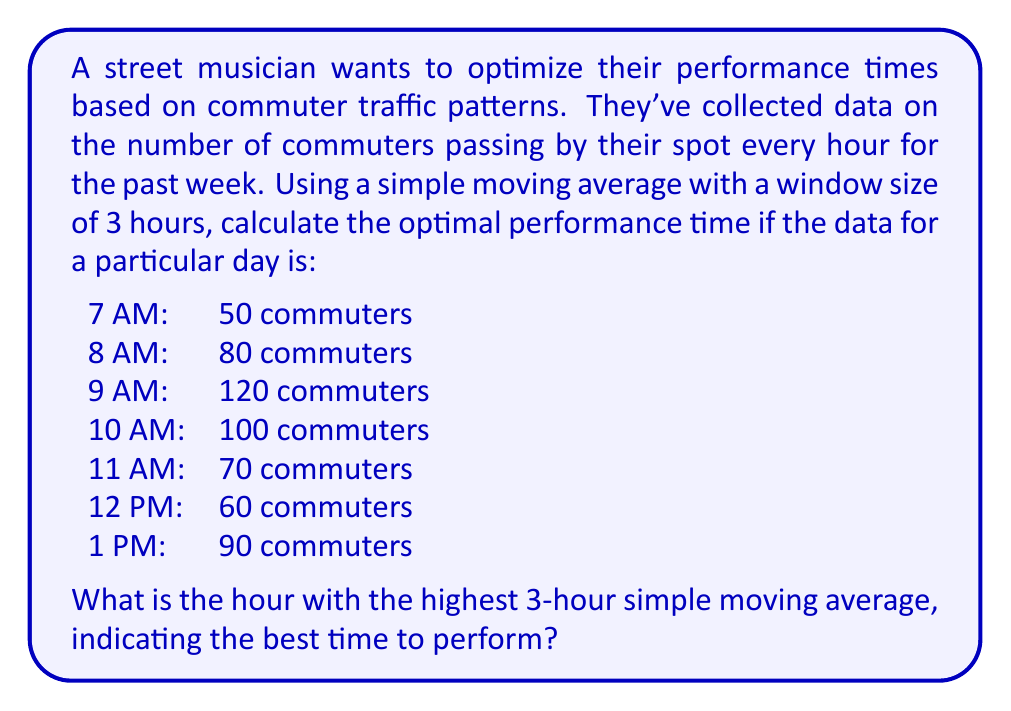Give your solution to this math problem. To solve this problem, we need to calculate the 3-hour simple moving average for each time slot and find the highest value. The simple moving average is calculated by taking the average of the current hour and the two preceding hours.

Let's calculate the moving averages:

1. For 9 AM:
   $$ SMA_{9AM} = \frac{50 + 80 + 120}{3} = \frac{250}{3} \approx 83.33 $$

2. For 10 AM:
   $$ SMA_{10AM} = \frac{80 + 120 + 100}{3} = \frac{300}{3} = 100 $$

3. For 11 AM:
   $$ SMA_{11AM} = \frac{120 + 100 + 70}{3} = \frac{290}{3} \approx 96.67 $$

4. For 12 PM:
   $$ SMA_{12PM} = \frac{100 + 70 + 60}{3} = \frac{230}{3} \approx 76.67 $$

5. For 1 PM:
   $$ SMA_{1PM} = \frac{70 + 60 + 90}{3} = \frac{220}{3} \approx 73.33 $$

The highest 3-hour simple moving average is 100, which occurs at 10 AM. This indicates that the period from 8 AM to 10 AM has the highest average number of commuters, making it the optimal time for the musician to perform.
Answer: 10 AM 